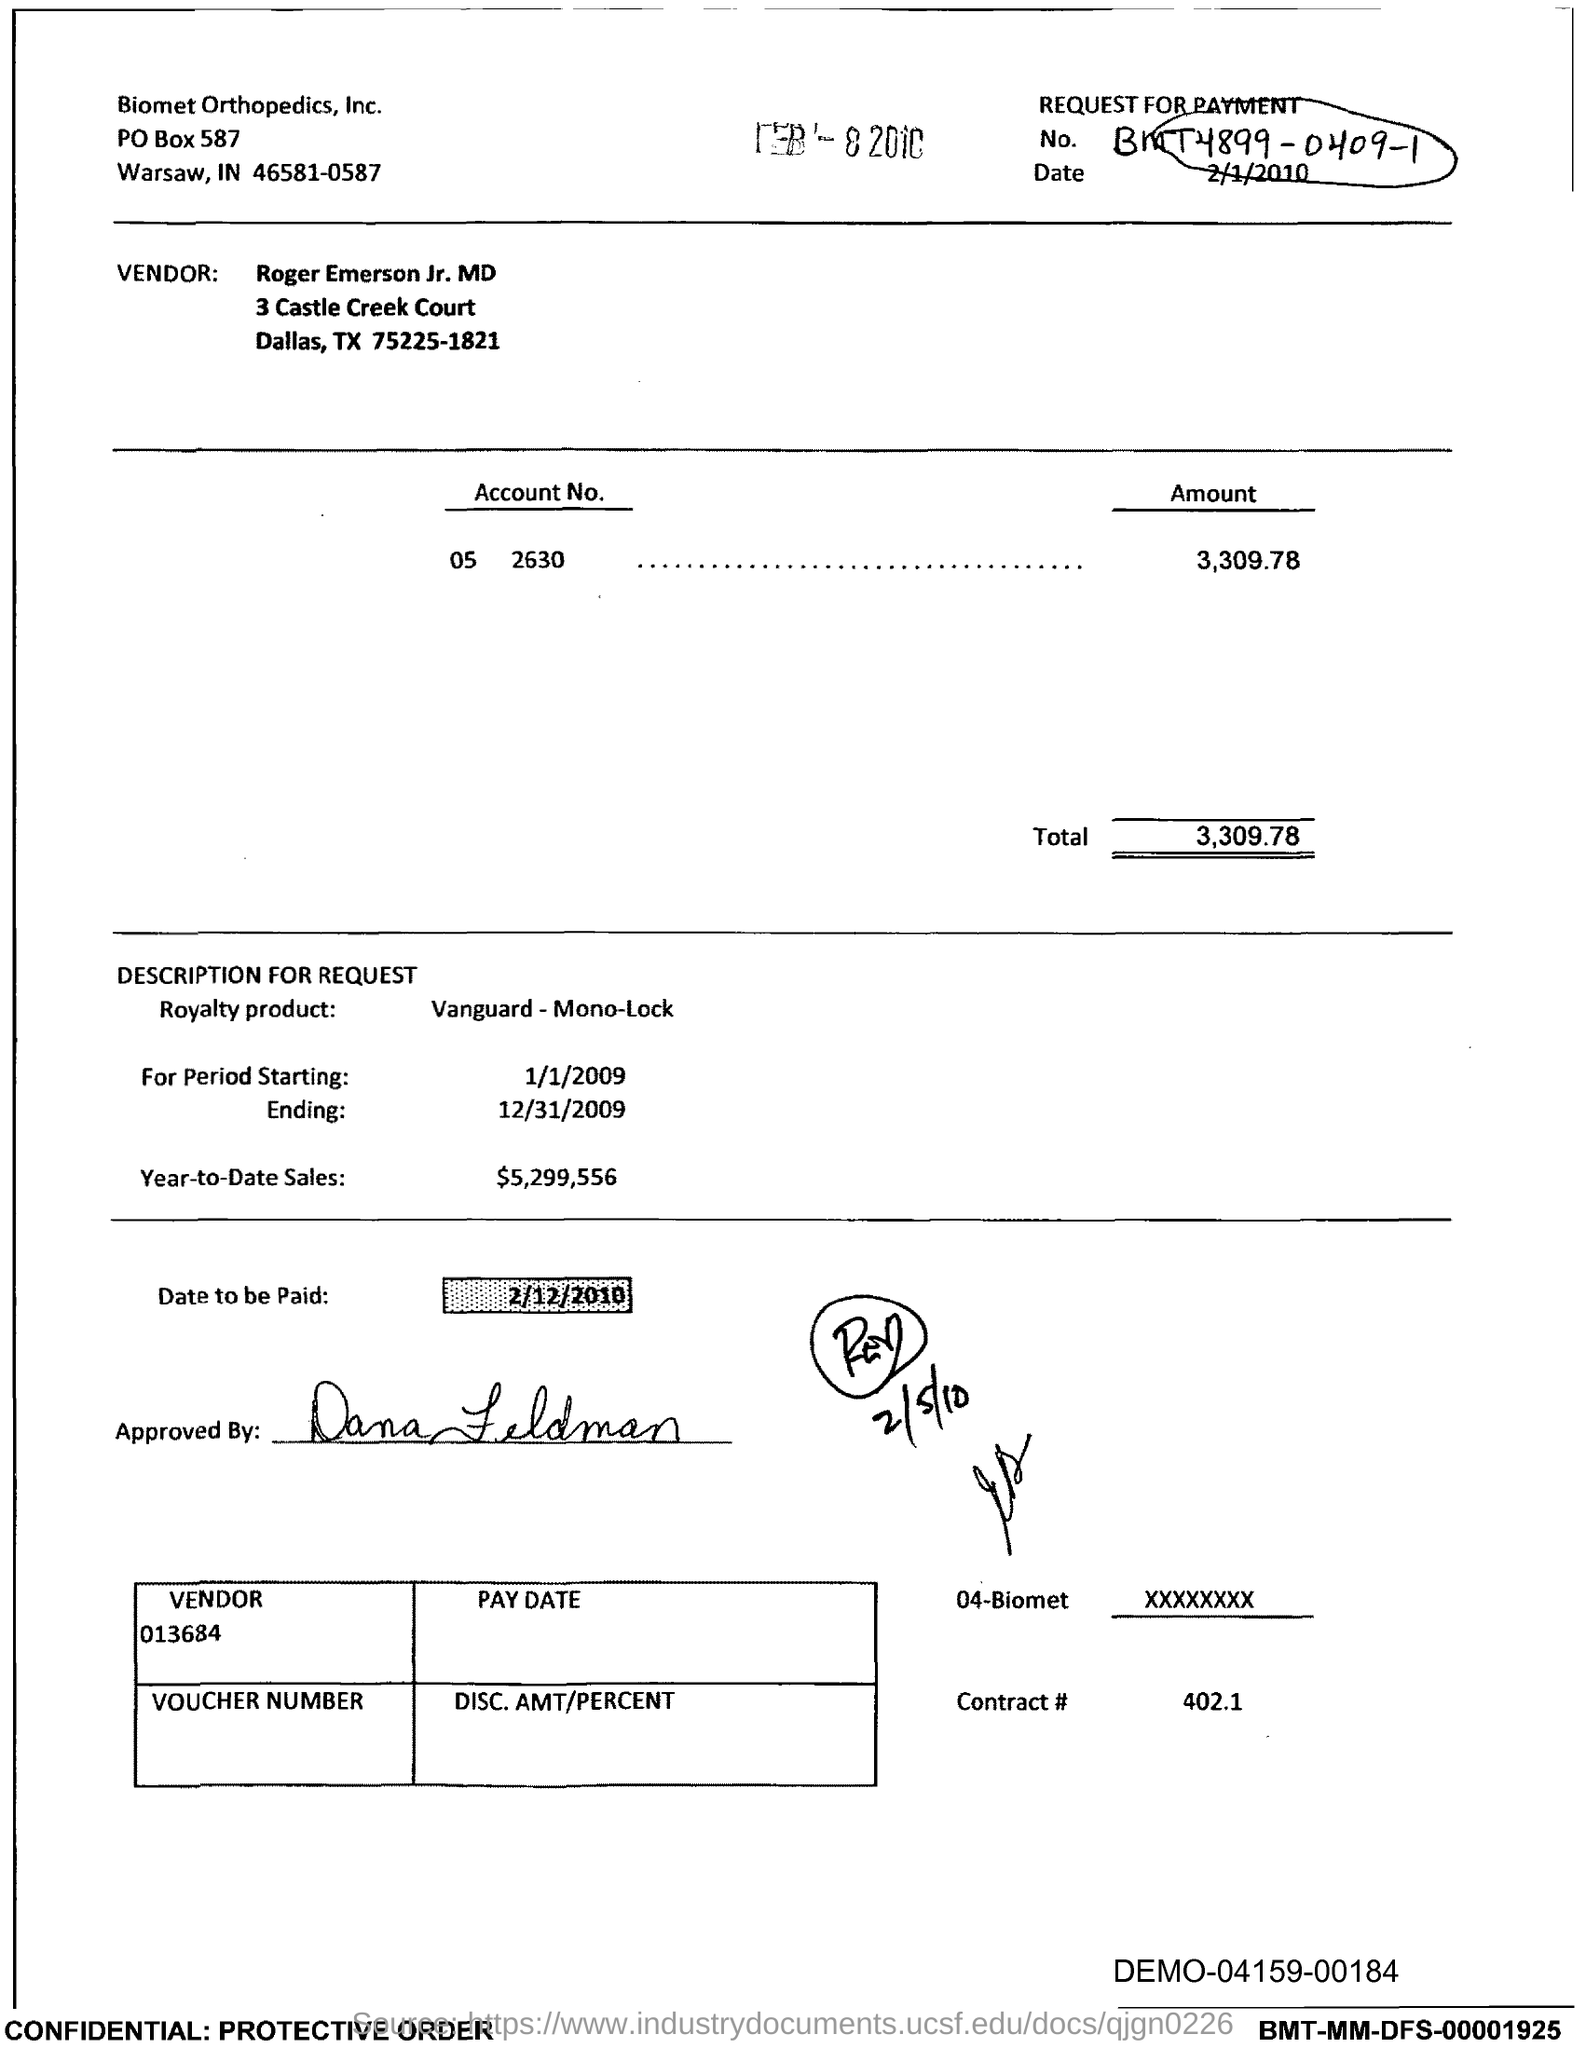List a handful of essential elements in this visual. Year-to-date sales as of the current date are $5,299,556. What is Contract # Number 402.1..?" is a question that requires a response. Please provide the date on which the payment is due, which is 2/12/2010. 